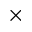<formula> <loc_0><loc_0><loc_500><loc_500>\times</formula> 